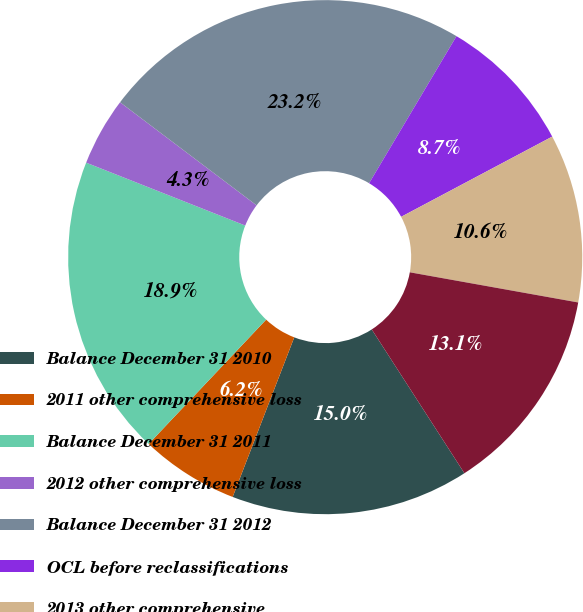Convert chart to OTSL. <chart><loc_0><loc_0><loc_500><loc_500><pie_chart><fcel>Balance December 31 2010<fcel>2011 other comprehensive loss<fcel>Balance December 31 2011<fcel>2012 other comprehensive loss<fcel>Balance December 31 2012<fcel>OCL before reclassifications<fcel>2013 other comprehensive<fcel>Balance December 31 2013<nl><fcel>14.97%<fcel>6.19%<fcel>18.94%<fcel>4.3%<fcel>23.24%<fcel>8.7%<fcel>10.59%<fcel>13.07%<nl></chart> 